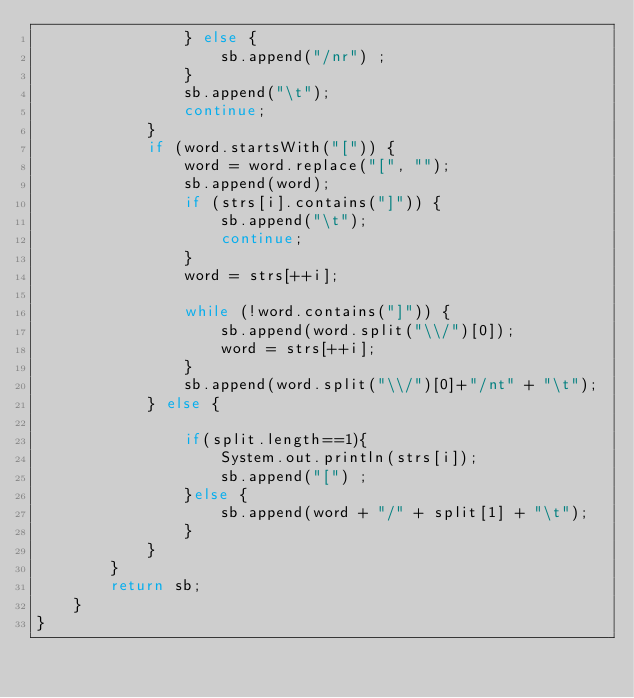<code> <loc_0><loc_0><loc_500><loc_500><_Java_>				} else {
					sb.append("/nr") ;
				}
				sb.append("\t");
				continue;
			}
			if (word.startsWith("[")) {
				word = word.replace("[", "");
				sb.append(word);
				if (strs[i].contains("]")) {
					sb.append("\t");
					continue;
				}
				word = strs[++i];

				while (!word.contains("]")) {
					sb.append(word.split("\\/")[0]);
					word = strs[++i];
				}
				sb.append(word.split("\\/")[0]+"/nt" + "\t");
			} else {

				if(split.length==1){
					System.out.println(strs[i]);
					sb.append("[") ;
				}else {
					sb.append(word + "/" + split[1] + "\t");
				}
			}
		}
		return sb;
	}
}
</code> 